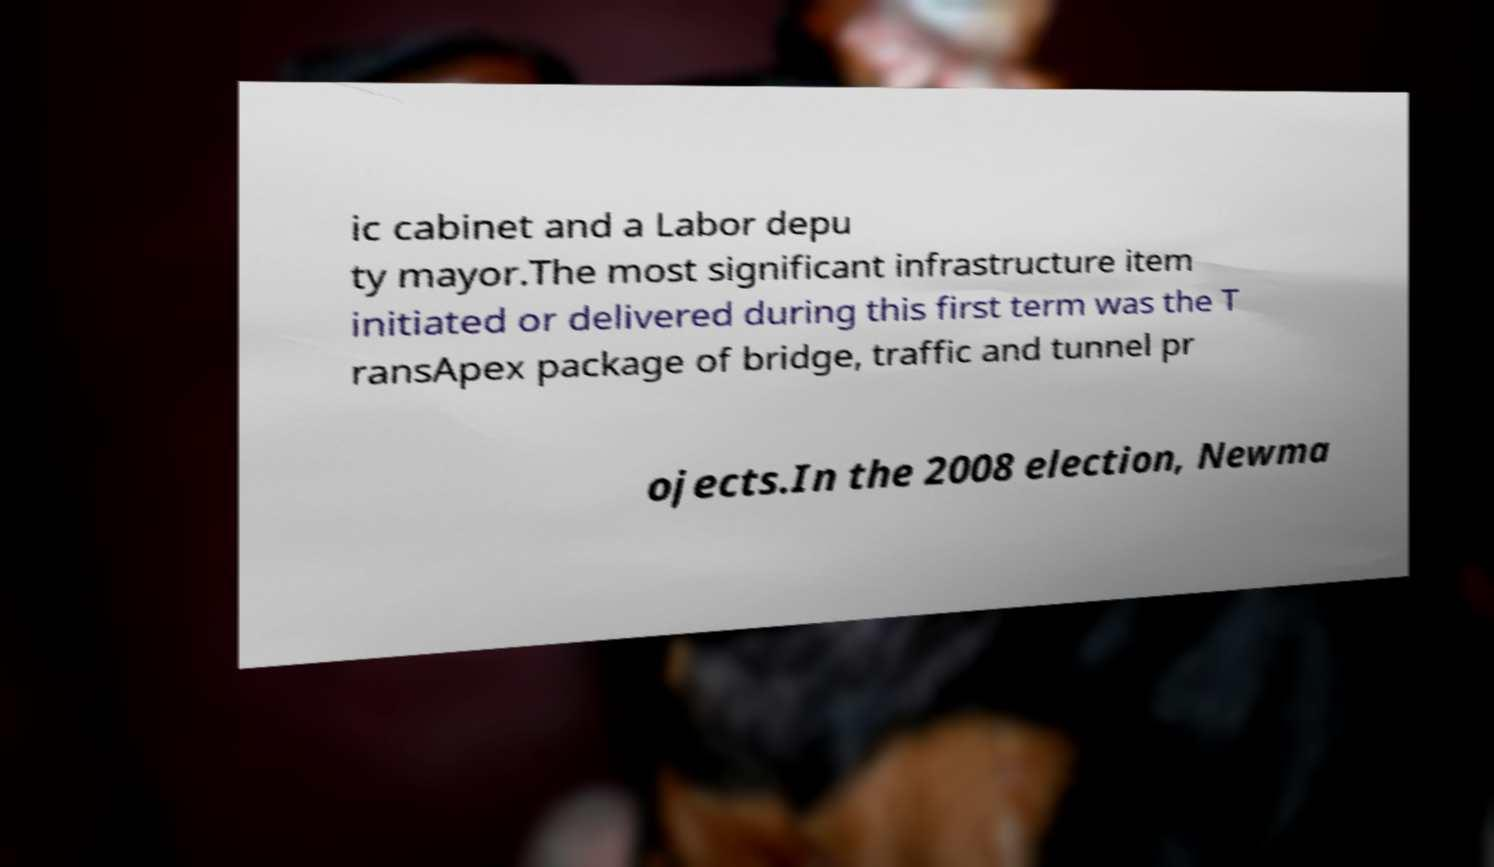Can you read and provide the text displayed in the image?This photo seems to have some interesting text. Can you extract and type it out for me? ic cabinet and a Labor depu ty mayor.The most significant infrastructure item initiated or delivered during this first term was the T ransApex package of bridge, traffic and tunnel pr ojects.In the 2008 election, Newma 